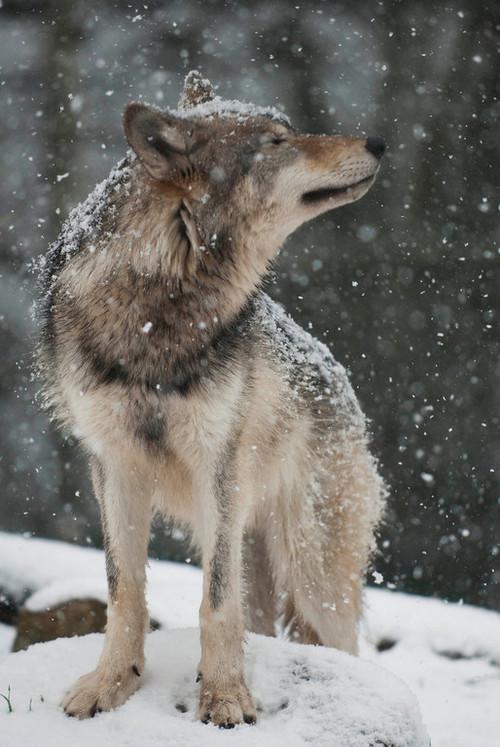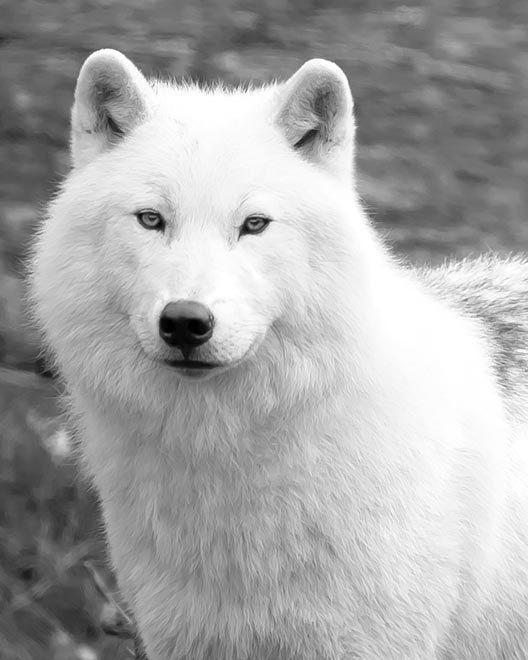The first image is the image on the left, the second image is the image on the right. Analyze the images presented: Is the assertion "The animal in the image on the right has a white coat." valid? Answer yes or no. Yes. 